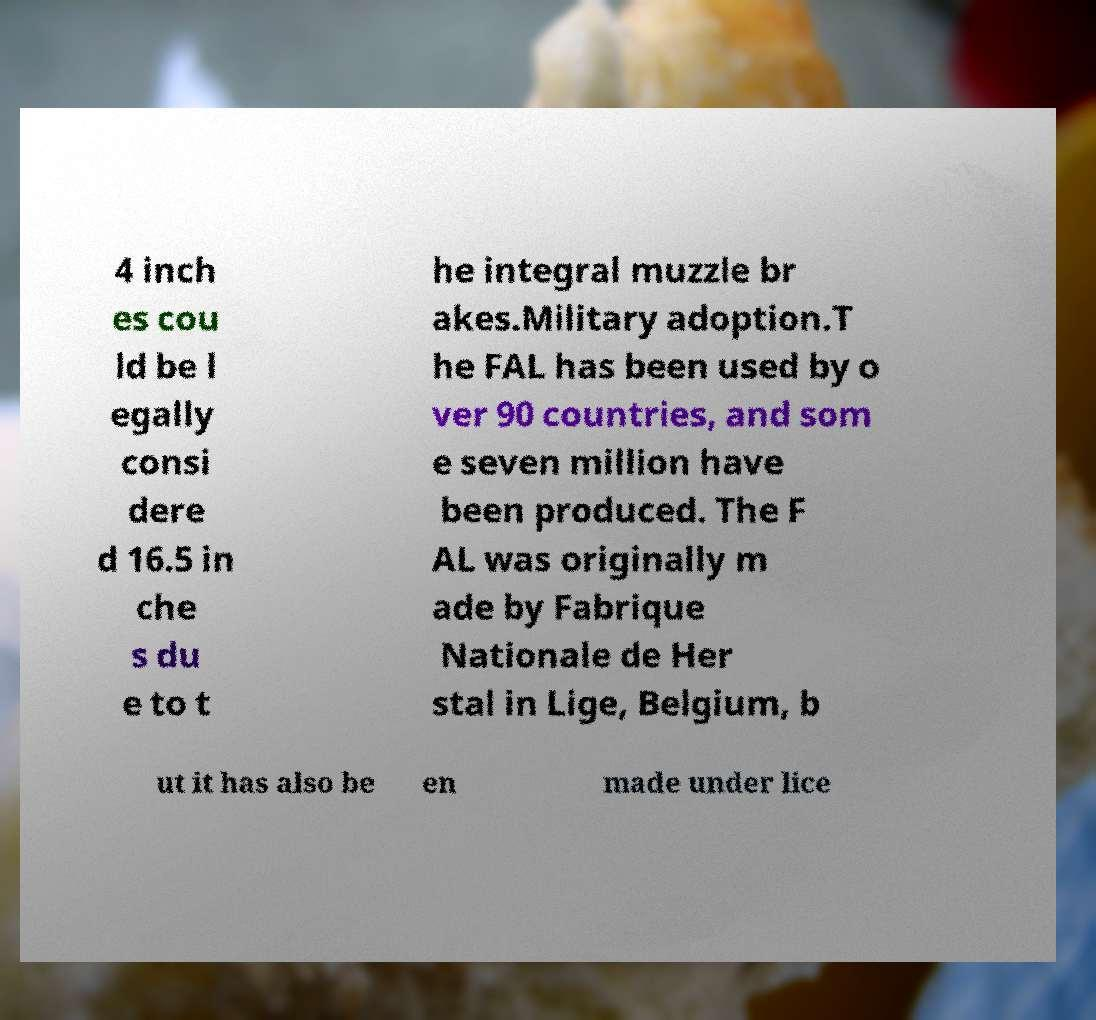What messages or text are displayed in this image? I need them in a readable, typed format. 4 inch es cou ld be l egally consi dere d 16.5 in che s du e to t he integral muzzle br akes.Military adoption.T he FAL has been used by o ver 90 countries, and som e seven million have been produced. The F AL was originally m ade by Fabrique Nationale de Her stal in Lige, Belgium, b ut it has also be en made under lice 